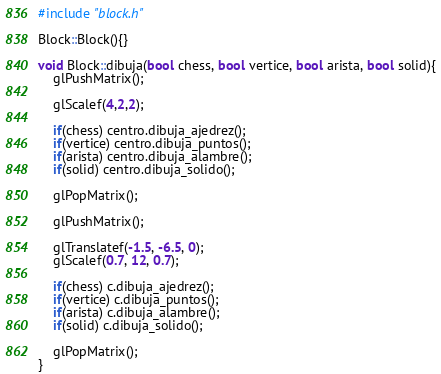<code> <loc_0><loc_0><loc_500><loc_500><_C++_>#include "block.h"

Block::Block(){}

void Block::dibuja(bool chess, bool vertice, bool arista, bool solid){
	glPushMatrix();

	glScalef(4,2,2);

	if(chess) centro.dibuja_ajedrez();
	if(vertice) centro.dibuja_puntos();
	if(arista) centro.dibuja_alambre();
	if(solid) centro.dibuja_solido();

	glPopMatrix();

	glPushMatrix();

	glTranslatef(-1.5, -6.5, 0);
	glScalef(0.7, 12, 0.7);

	if(chess) c.dibuja_ajedrez();
	if(vertice) c.dibuja_puntos();
	if(arista) c.dibuja_alambre();
	if(solid) c.dibuja_solido();

	glPopMatrix();
}
</code> 